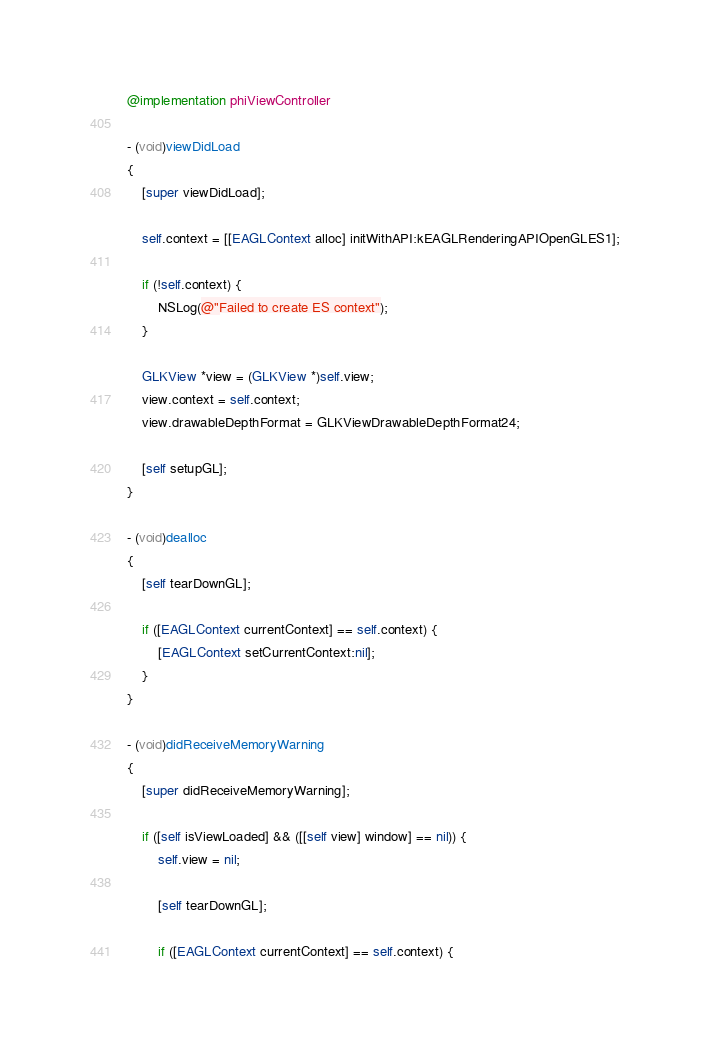<code> <loc_0><loc_0><loc_500><loc_500><_ObjectiveC_>
@implementation phiViewController

- (void)viewDidLoad
{
    [super viewDidLoad];
    
    self.context = [[EAGLContext alloc] initWithAPI:kEAGLRenderingAPIOpenGLES1];

    if (!self.context) {
        NSLog(@"Failed to create ES context");
    }
    
    GLKView *view = (GLKView *)self.view;
    view.context = self.context;
    view.drawableDepthFormat = GLKViewDrawableDepthFormat24;
    
    [self setupGL];
}

- (void)dealloc
{    
    [self tearDownGL];
    
    if ([EAGLContext currentContext] == self.context) {
        [EAGLContext setCurrentContext:nil];
    }
}

- (void)didReceiveMemoryWarning
{
    [super didReceiveMemoryWarning];

    if ([self isViewLoaded] && ([[self view] window] == nil)) {
        self.view = nil;
        
        [self tearDownGL];
        
        if ([EAGLContext currentContext] == self.context) {</code> 